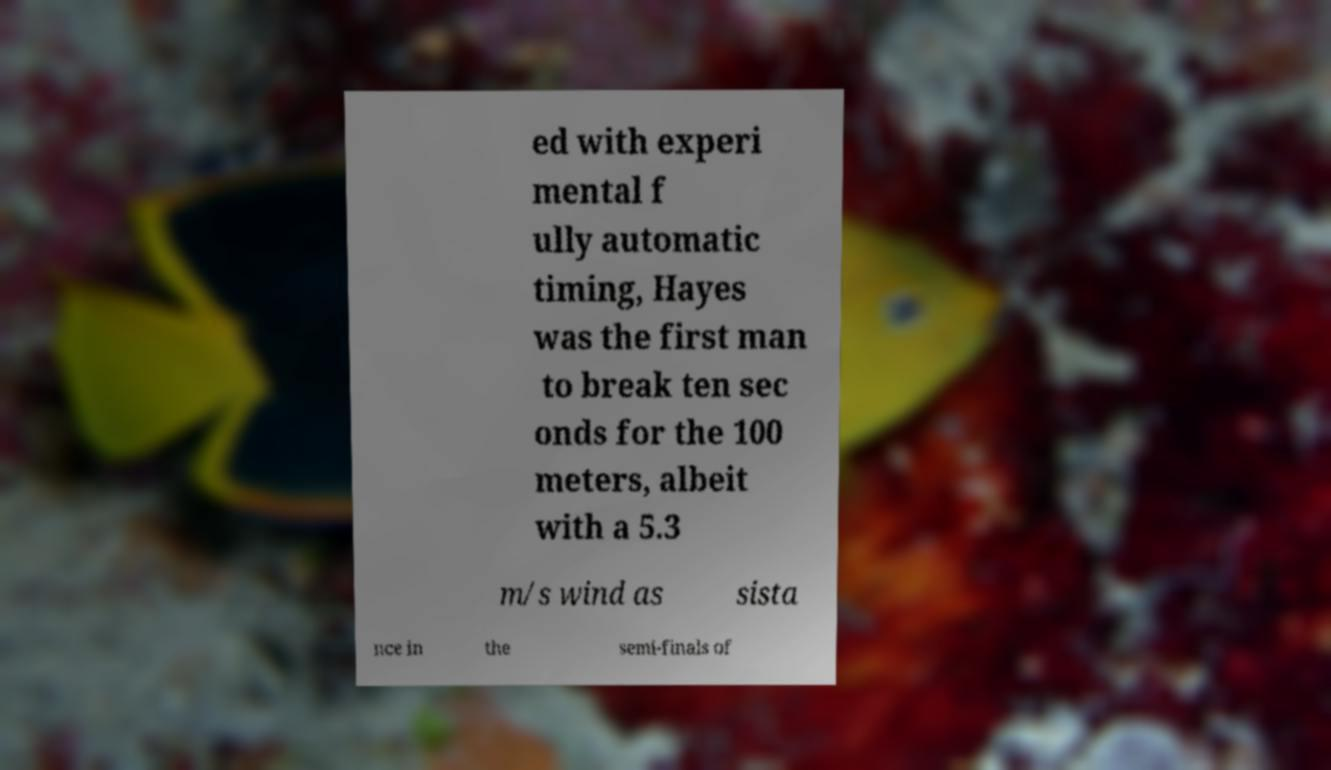Please identify and transcribe the text found in this image. ed with experi mental f ully automatic timing, Hayes was the first man to break ten sec onds for the 100 meters, albeit with a 5.3 m/s wind as sista nce in the semi-finals of 